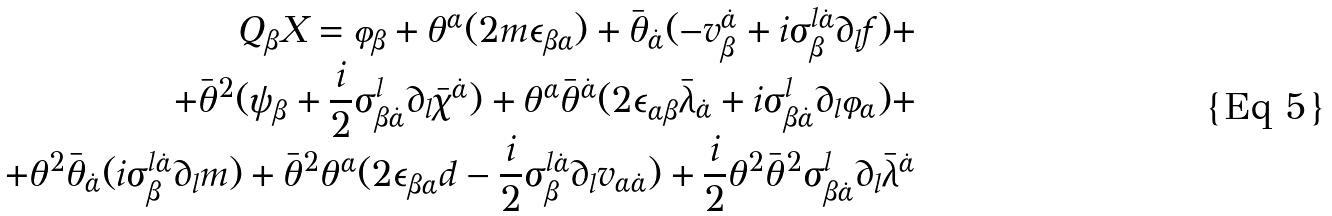<formula> <loc_0><loc_0><loc_500><loc_500>Q _ { \beta } X = \varphi _ { \beta } + \theta ^ { \alpha } ( 2 m \epsilon _ { \beta \alpha } ) + \bar { \theta } _ { \dot { \alpha } } ( - v _ { \beta } ^ { \dot { \alpha } } + i \sigma _ { \beta } ^ { l \dot { \alpha } } \partial _ { l } f ) + \\ + \bar { \theta } ^ { 2 } ( \psi _ { \beta } + \frac { i } { 2 } \sigma _ { \beta \dot { \alpha } } ^ { l } \partial _ { l } \bar { \chi } ^ { \dot { \alpha } } ) + \theta ^ { \alpha } \bar { \theta } ^ { \dot { \alpha } } ( 2 \epsilon _ { \alpha \beta } \bar { \lambda } _ { \dot { \alpha } } + i \sigma _ { \beta \dot { \alpha } } ^ { l } \partial _ { l } \varphi _ { \alpha } ) + \\ + \theta ^ { 2 } \bar { \theta } _ { \dot { \alpha } } ( i \sigma _ { \beta } ^ { l \dot { \alpha } } \partial _ { l } m ) + \bar { \theta } ^ { 2 } \theta ^ { \alpha } ( 2 \epsilon _ { \beta \alpha } d - \frac { i } { 2 } \sigma _ { \beta } ^ { l \dot { \alpha } } \partial _ { l } v _ { \alpha \dot { \alpha } } ) + \frac { i } { 2 } \theta ^ { 2 } \bar { \theta } ^ { 2 } \sigma _ { \beta \dot { \alpha } } ^ { l } \partial _ { l } \bar { \lambda } ^ { \dot { \alpha } }</formula> 